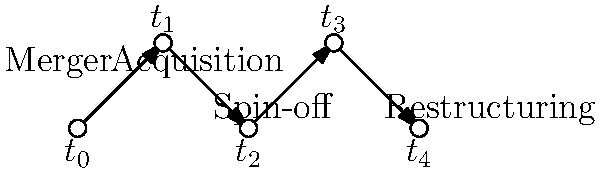In the organizational chart above, which corporate event occurs between time points $t_2$ and $t_3$, and how might this impact the company's structure and potential areas for investigation? To answer this question, we need to analyze the organizational chart and understand the sequence of events:

1. Identify the event between $t_2$ and $t_3$:
   - The chart shows an "Acquisition" event occurring between these two time points.

2. Understand the impact of an acquisition on corporate structure:
   - An acquisition involves one company purchasing another company or its assets.
   - This typically leads to an expansion of the acquiring company's size, resources, and market presence.

3. Consider potential areas for investigation:
   a) Financial transactions: Large sums of money are involved in acquisitions, which may require scrutiny.
   b) Due diligence: Investigate whether proper vetting of the acquired company was conducted.
   c) Integration process: Examine how the acquired company's assets, employees, and operations are being incorporated.
   d) Regulatory compliance: Ensure the acquisition adheres to antitrust laws and other relevant regulations.
   e) Corporate governance: Investigate any changes in leadership or decision-making structures post-acquisition.
   f) Synergies and redundancies: Look into how the company plans to leverage new assets and handle potential job duplications.

4. Impact on investigation approach:
   - The acquisition event suggests a need to broaden the scope of the investigation to include both the acquiring and acquired companies.
   - Focus on the period leading up to the acquisition and the immediate aftermath for potential irregularities or malpractices.
Answer: Acquisition; expands company size and scope, requires investigation into financial transactions, due diligence, integration process, regulatory compliance, corporate governance changes, and potential synergies or redundancies. 